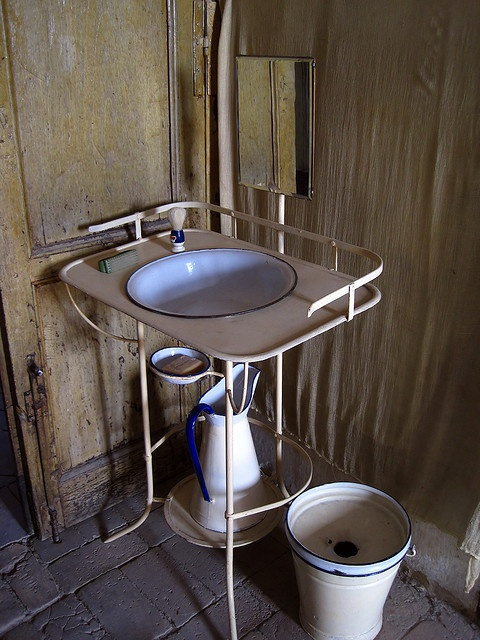Describe the objects in this image and their specific colors. I can see a sink in gray and darkgray tones in this image. 